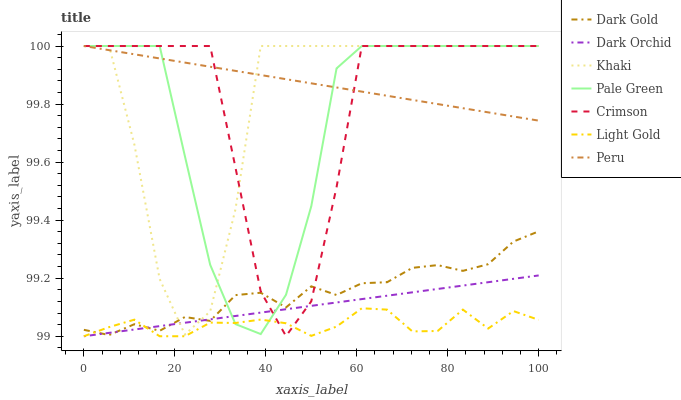Does Light Gold have the minimum area under the curve?
Answer yes or no. Yes. Does Peru have the maximum area under the curve?
Answer yes or no. Yes. Does Dark Gold have the minimum area under the curve?
Answer yes or no. No. Does Dark Gold have the maximum area under the curve?
Answer yes or no. No. Is Dark Orchid the smoothest?
Answer yes or no. Yes. Is Khaki the roughest?
Answer yes or no. Yes. Is Dark Gold the smoothest?
Answer yes or no. No. Is Dark Gold the roughest?
Answer yes or no. No. Does Dark Orchid have the lowest value?
Answer yes or no. Yes. Does Dark Gold have the lowest value?
Answer yes or no. No. Does Crimson have the highest value?
Answer yes or no. Yes. Does Dark Gold have the highest value?
Answer yes or no. No. Is Dark Gold less than Peru?
Answer yes or no. Yes. Is Peru greater than Dark Orchid?
Answer yes or no. Yes. Does Khaki intersect Pale Green?
Answer yes or no. Yes. Is Khaki less than Pale Green?
Answer yes or no. No. Is Khaki greater than Pale Green?
Answer yes or no. No. Does Dark Gold intersect Peru?
Answer yes or no. No. 